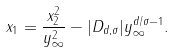Convert formula to latex. <formula><loc_0><loc_0><loc_500><loc_500>x _ { 1 } = \frac { x _ { 2 } ^ { 2 } } { y _ { \infty } ^ { 2 } } - | D _ { d , \sigma } | y _ { \infty } ^ { d / \sigma - 1 } .</formula> 